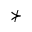Convert formula to latex. <formula><loc_0><loc_0><loc_500><loc_500>\nsucc</formula> 